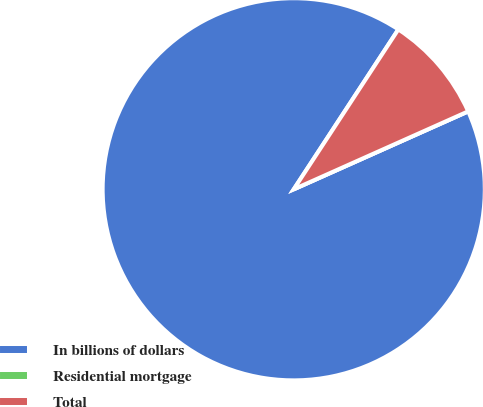Convert chart. <chart><loc_0><loc_0><loc_500><loc_500><pie_chart><fcel>In billions of dollars<fcel>Residential mortgage<fcel>Total<nl><fcel>90.9%<fcel>0.0%<fcel>9.09%<nl></chart> 